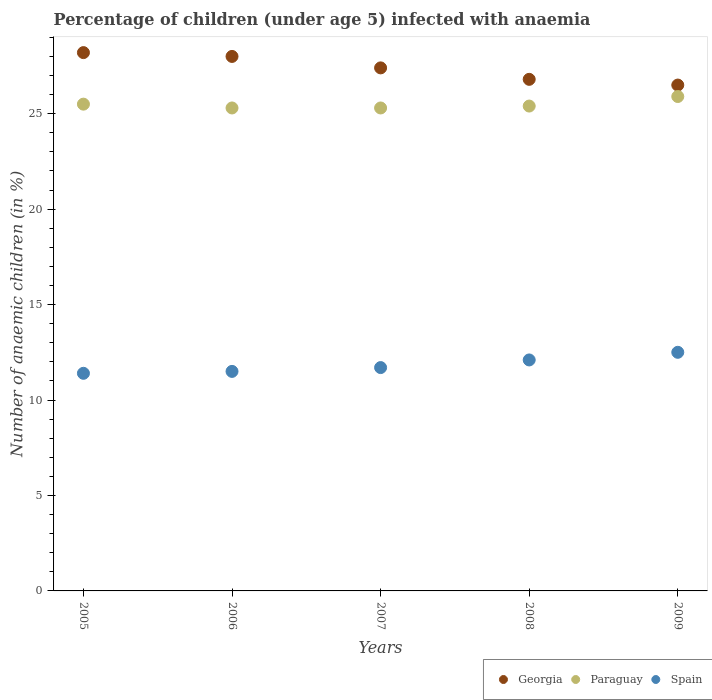Is the number of dotlines equal to the number of legend labels?
Offer a terse response. Yes. Across all years, what is the maximum percentage of children infected with anaemia in in Spain?
Provide a short and direct response. 12.5. Across all years, what is the minimum percentage of children infected with anaemia in in Spain?
Provide a short and direct response. 11.4. In which year was the percentage of children infected with anaemia in in Georgia maximum?
Make the answer very short. 2005. In which year was the percentage of children infected with anaemia in in Georgia minimum?
Provide a short and direct response. 2009. What is the total percentage of children infected with anaemia in in Georgia in the graph?
Ensure brevity in your answer.  136.9. What is the difference between the percentage of children infected with anaemia in in Spain in 2005 and that in 2007?
Give a very brief answer. -0.3. What is the average percentage of children infected with anaemia in in Paraguay per year?
Ensure brevity in your answer.  25.48. In the year 2009, what is the difference between the percentage of children infected with anaemia in in Paraguay and percentage of children infected with anaemia in in Georgia?
Provide a short and direct response. -0.6. In how many years, is the percentage of children infected with anaemia in in Georgia greater than 3 %?
Offer a terse response. 5. Is the percentage of children infected with anaemia in in Georgia in 2005 less than that in 2008?
Keep it short and to the point. No. What is the difference between the highest and the second highest percentage of children infected with anaemia in in Georgia?
Keep it short and to the point. 0.2. What is the difference between the highest and the lowest percentage of children infected with anaemia in in Spain?
Ensure brevity in your answer.  1.1. In how many years, is the percentage of children infected with anaemia in in Georgia greater than the average percentage of children infected with anaemia in in Georgia taken over all years?
Keep it short and to the point. 3. Is the sum of the percentage of children infected with anaemia in in Georgia in 2007 and 2009 greater than the maximum percentage of children infected with anaemia in in Paraguay across all years?
Ensure brevity in your answer.  Yes. Is it the case that in every year, the sum of the percentage of children infected with anaemia in in Spain and percentage of children infected with anaemia in in Georgia  is greater than the percentage of children infected with anaemia in in Paraguay?
Provide a succinct answer. Yes. Is the percentage of children infected with anaemia in in Georgia strictly less than the percentage of children infected with anaemia in in Spain over the years?
Offer a terse response. No. How many dotlines are there?
Ensure brevity in your answer.  3. Does the graph contain any zero values?
Make the answer very short. No. Does the graph contain grids?
Provide a short and direct response. No. Where does the legend appear in the graph?
Your answer should be very brief. Bottom right. How many legend labels are there?
Your answer should be very brief. 3. How are the legend labels stacked?
Give a very brief answer. Horizontal. What is the title of the graph?
Your answer should be very brief. Percentage of children (under age 5) infected with anaemia. Does "Libya" appear as one of the legend labels in the graph?
Offer a very short reply. No. What is the label or title of the Y-axis?
Provide a succinct answer. Number of anaemic children (in %). What is the Number of anaemic children (in %) of Georgia in 2005?
Provide a short and direct response. 28.2. What is the Number of anaemic children (in %) in Paraguay in 2005?
Your answer should be very brief. 25.5. What is the Number of anaemic children (in %) in Georgia in 2006?
Your response must be concise. 28. What is the Number of anaemic children (in %) in Paraguay in 2006?
Offer a terse response. 25.3. What is the Number of anaemic children (in %) of Spain in 2006?
Provide a short and direct response. 11.5. What is the Number of anaemic children (in %) of Georgia in 2007?
Your answer should be compact. 27.4. What is the Number of anaemic children (in %) of Paraguay in 2007?
Keep it short and to the point. 25.3. What is the Number of anaemic children (in %) of Spain in 2007?
Your response must be concise. 11.7. What is the Number of anaemic children (in %) in Georgia in 2008?
Make the answer very short. 26.8. What is the Number of anaemic children (in %) in Paraguay in 2008?
Your answer should be very brief. 25.4. What is the Number of anaemic children (in %) of Spain in 2008?
Your answer should be very brief. 12.1. What is the Number of anaemic children (in %) of Georgia in 2009?
Keep it short and to the point. 26.5. What is the Number of anaemic children (in %) in Paraguay in 2009?
Your answer should be compact. 25.9. What is the Number of anaemic children (in %) of Spain in 2009?
Keep it short and to the point. 12.5. Across all years, what is the maximum Number of anaemic children (in %) in Georgia?
Offer a very short reply. 28.2. Across all years, what is the maximum Number of anaemic children (in %) of Paraguay?
Ensure brevity in your answer.  25.9. Across all years, what is the minimum Number of anaemic children (in %) of Georgia?
Make the answer very short. 26.5. Across all years, what is the minimum Number of anaemic children (in %) of Paraguay?
Offer a terse response. 25.3. What is the total Number of anaemic children (in %) in Georgia in the graph?
Offer a terse response. 136.9. What is the total Number of anaemic children (in %) in Paraguay in the graph?
Offer a terse response. 127.4. What is the total Number of anaemic children (in %) in Spain in the graph?
Provide a succinct answer. 59.2. What is the difference between the Number of anaemic children (in %) of Georgia in 2005 and that in 2006?
Your answer should be compact. 0.2. What is the difference between the Number of anaemic children (in %) in Spain in 2005 and that in 2006?
Your answer should be very brief. -0.1. What is the difference between the Number of anaemic children (in %) in Paraguay in 2005 and that in 2007?
Provide a succinct answer. 0.2. What is the difference between the Number of anaemic children (in %) in Paraguay in 2005 and that in 2008?
Keep it short and to the point. 0.1. What is the difference between the Number of anaemic children (in %) in Spain in 2005 and that in 2008?
Offer a very short reply. -0.7. What is the difference between the Number of anaemic children (in %) in Paraguay in 2005 and that in 2009?
Ensure brevity in your answer.  -0.4. What is the difference between the Number of anaemic children (in %) of Spain in 2005 and that in 2009?
Keep it short and to the point. -1.1. What is the difference between the Number of anaemic children (in %) of Paraguay in 2006 and that in 2007?
Ensure brevity in your answer.  0. What is the difference between the Number of anaemic children (in %) of Spain in 2006 and that in 2007?
Ensure brevity in your answer.  -0.2. What is the difference between the Number of anaemic children (in %) in Georgia in 2006 and that in 2008?
Offer a very short reply. 1.2. What is the difference between the Number of anaemic children (in %) in Paraguay in 2006 and that in 2008?
Your answer should be compact. -0.1. What is the difference between the Number of anaemic children (in %) of Spain in 2006 and that in 2008?
Provide a succinct answer. -0.6. What is the difference between the Number of anaemic children (in %) in Georgia in 2006 and that in 2009?
Offer a terse response. 1.5. What is the difference between the Number of anaemic children (in %) in Georgia in 2007 and that in 2008?
Provide a succinct answer. 0.6. What is the difference between the Number of anaemic children (in %) in Paraguay in 2007 and that in 2008?
Provide a succinct answer. -0.1. What is the difference between the Number of anaemic children (in %) in Georgia in 2008 and that in 2009?
Provide a short and direct response. 0.3. What is the difference between the Number of anaemic children (in %) of Spain in 2008 and that in 2009?
Your response must be concise. -0.4. What is the difference between the Number of anaemic children (in %) of Georgia in 2005 and the Number of anaemic children (in %) of Paraguay in 2006?
Ensure brevity in your answer.  2.9. What is the difference between the Number of anaemic children (in %) of Georgia in 2005 and the Number of anaemic children (in %) of Paraguay in 2008?
Give a very brief answer. 2.8. What is the difference between the Number of anaemic children (in %) of Georgia in 2005 and the Number of anaemic children (in %) of Spain in 2008?
Provide a succinct answer. 16.1. What is the difference between the Number of anaemic children (in %) of Paraguay in 2005 and the Number of anaemic children (in %) of Spain in 2008?
Give a very brief answer. 13.4. What is the difference between the Number of anaemic children (in %) of Georgia in 2005 and the Number of anaemic children (in %) of Paraguay in 2009?
Make the answer very short. 2.3. What is the difference between the Number of anaemic children (in %) in Georgia in 2005 and the Number of anaemic children (in %) in Spain in 2009?
Offer a terse response. 15.7. What is the difference between the Number of anaemic children (in %) of Georgia in 2006 and the Number of anaemic children (in %) of Paraguay in 2007?
Ensure brevity in your answer.  2.7. What is the difference between the Number of anaemic children (in %) in Georgia in 2006 and the Number of anaemic children (in %) in Spain in 2007?
Your answer should be compact. 16.3. What is the difference between the Number of anaemic children (in %) of Paraguay in 2006 and the Number of anaemic children (in %) of Spain in 2007?
Provide a short and direct response. 13.6. What is the difference between the Number of anaemic children (in %) of Georgia in 2006 and the Number of anaemic children (in %) of Spain in 2008?
Provide a succinct answer. 15.9. What is the difference between the Number of anaemic children (in %) of Georgia in 2006 and the Number of anaemic children (in %) of Paraguay in 2009?
Provide a short and direct response. 2.1. What is the difference between the Number of anaemic children (in %) of Paraguay in 2006 and the Number of anaemic children (in %) of Spain in 2009?
Provide a succinct answer. 12.8. What is the difference between the Number of anaemic children (in %) in Georgia in 2007 and the Number of anaemic children (in %) in Spain in 2008?
Keep it short and to the point. 15.3. What is the difference between the Number of anaemic children (in %) of Georgia in 2007 and the Number of anaemic children (in %) of Spain in 2009?
Provide a succinct answer. 14.9. What is the difference between the Number of anaemic children (in %) of Paraguay in 2007 and the Number of anaemic children (in %) of Spain in 2009?
Make the answer very short. 12.8. What is the difference between the Number of anaemic children (in %) of Georgia in 2008 and the Number of anaemic children (in %) of Paraguay in 2009?
Give a very brief answer. 0.9. What is the difference between the Number of anaemic children (in %) of Georgia in 2008 and the Number of anaemic children (in %) of Spain in 2009?
Your answer should be compact. 14.3. What is the difference between the Number of anaemic children (in %) of Paraguay in 2008 and the Number of anaemic children (in %) of Spain in 2009?
Provide a short and direct response. 12.9. What is the average Number of anaemic children (in %) of Georgia per year?
Your answer should be very brief. 27.38. What is the average Number of anaemic children (in %) of Paraguay per year?
Provide a short and direct response. 25.48. What is the average Number of anaemic children (in %) of Spain per year?
Make the answer very short. 11.84. In the year 2005, what is the difference between the Number of anaemic children (in %) of Georgia and Number of anaemic children (in %) of Paraguay?
Your answer should be very brief. 2.7. In the year 2005, what is the difference between the Number of anaemic children (in %) of Paraguay and Number of anaemic children (in %) of Spain?
Offer a very short reply. 14.1. In the year 2006, what is the difference between the Number of anaemic children (in %) of Georgia and Number of anaemic children (in %) of Paraguay?
Give a very brief answer. 2.7. In the year 2006, what is the difference between the Number of anaemic children (in %) in Georgia and Number of anaemic children (in %) in Spain?
Your response must be concise. 16.5. In the year 2007, what is the difference between the Number of anaemic children (in %) of Georgia and Number of anaemic children (in %) of Paraguay?
Provide a short and direct response. 2.1. In the year 2007, what is the difference between the Number of anaemic children (in %) in Georgia and Number of anaemic children (in %) in Spain?
Ensure brevity in your answer.  15.7. In the year 2008, what is the difference between the Number of anaemic children (in %) in Paraguay and Number of anaemic children (in %) in Spain?
Make the answer very short. 13.3. What is the ratio of the Number of anaemic children (in %) of Georgia in 2005 to that in 2006?
Keep it short and to the point. 1.01. What is the ratio of the Number of anaemic children (in %) in Paraguay in 2005 to that in 2006?
Your answer should be very brief. 1.01. What is the ratio of the Number of anaemic children (in %) of Georgia in 2005 to that in 2007?
Ensure brevity in your answer.  1.03. What is the ratio of the Number of anaemic children (in %) of Paraguay in 2005 to that in 2007?
Provide a succinct answer. 1.01. What is the ratio of the Number of anaemic children (in %) in Spain in 2005 to that in 2007?
Offer a very short reply. 0.97. What is the ratio of the Number of anaemic children (in %) of Georgia in 2005 to that in 2008?
Ensure brevity in your answer.  1.05. What is the ratio of the Number of anaemic children (in %) in Paraguay in 2005 to that in 2008?
Make the answer very short. 1. What is the ratio of the Number of anaemic children (in %) of Spain in 2005 to that in 2008?
Give a very brief answer. 0.94. What is the ratio of the Number of anaemic children (in %) in Georgia in 2005 to that in 2009?
Make the answer very short. 1.06. What is the ratio of the Number of anaemic children (in %) of Paraguay in 2005 to that in 2009?
Your answer should be compact. 0.98. What is the ratio of the Number of anaemic children (in %) in Spain in 2005 to that in 2009?
Provide a short and direct response. 0.91. What is the ratio of the Number of anaemic children (in %) in Georgia in 2006 to that in 2007?
Keep it short and to the point. 1.02. What is the ratio of the Number of anaemic children (in %) in Paraguay in 2006 to that in 2007?
Provide a short and direct response. 1. What is the ratio of the Number of anaemic children (in %) in Spain in 2006 to that in 2007?
Offer a terse response. 0.98. What is the ratio of the Number of anaemic children (in %) of Georgia in 2006 to that in 2008?
Your answer should be compact. 1.04. What is the ratio of the Number of anaemic children (in %) of Paraguay in 2006 to that in 2008?
Your response must be concise. 1. What is the ratio of the Number of anaemic children (in %) of Spain in 2006 to that in 2008?
Offer a very short reply. 0.95. What is the ratio of the Number of anaemic children (in %) in Georgia in 2006 to that in 2009?
Give a very brief answer. 1.06. What is the ratio of the Number of anaemic children (in %) in Paraguay in 2006 to that in 2009?
Provide a succinct answer. 0.98. What is the ratio of the Number of anaemic children (in %) in Spain in 2006 to that in 2009?
Offer a terse response. 0.92. What is the ratio of the Number of anaemic children (in %) in Georgia in 2007 to that in 2008?
Keep it short and to the point. 1.02. What is the ratio of the Number of anaemic children (in %) of Paraguay in 2007 to that in 2008?
Your response must be concise. 1. What is the ratio of the Number of anaemic children (in %) of Spain in 2007 to that in 2008?
Offer a very short reply. 0.97. What is the ratio of the Number of anaemic children (in %) of Georgia in 2007 to that in 2009?
Provide a succinct answer. 1.03. What is the ratio of the Number of anaemic children (in %) of Paraguay in 2007 to that in 2009?
Provide a short and direct response. 0.98. What is the ratio of the Number of anaemic children (in %) of Spain in 2007 to that in 2009?
Make the answer very short. 0.94. What is the ratio of the Number of anaemic children (in %) in Georgia in 2008 to that in 2009?
Keep it short and to the point. 1.01. What is the ratio of the Number of anaemic children (in %) of Paraguay in 2008 to that in 2009?
Your answer should be very brief. 0.98. What is the difference between the highest and the second highest Number of anaemic children (in %) in Georgia?
Offer a terse response. 0.2. What is the difference between the highest and the lowest Number of anaemic children (in %) of Georgia?
Offer a very short reply. 1.7. What is the difference between the highest and the lowest Number of anaemic children (in %) of Spain?
Make the answer very short. 1.1. 